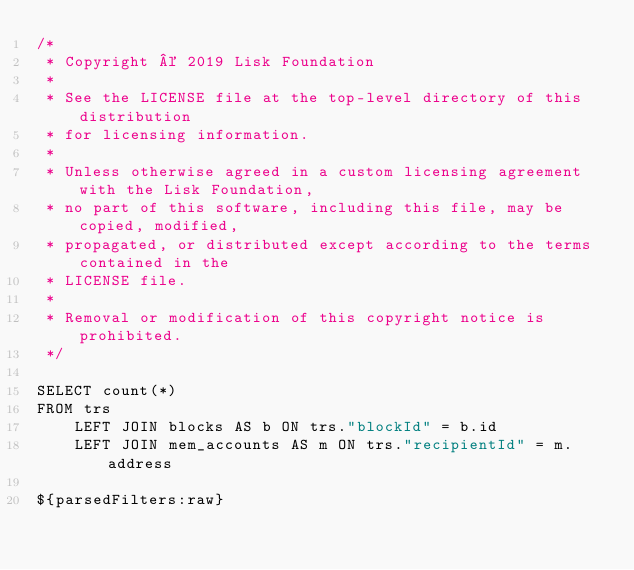<code> <loc_0><loc_0><loc_500><loc_500><_SQL_>/*
 * Copyright © 2019 Lisk Foundation
 *
 * See the LICENSE file at the top-level directory of this distribution
 * for licensing information.
 *
 * Unless otherwise agreed in a custom licensing agreement with the Lisk Foundation,
 * no part of this software, including this file, may be copied, modified,
 * propagated, or distributed except according to the terms contained in the
 * LICENSE file.
 *
 * Removal or modification of this copyright notice is prohibited.
 */

SELECT count(*)
FROM trs
	LEFT JOIN blocks AS b ON trs."blockId" = b.id
	LEFT JOIN mem_accounts AS m ON trs."recipientId" = m.address

${parsedFilters:raw}
</code> 